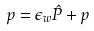Convert formula to latex. <formula><loc_0><loc_0><loc_500><loc_500>p = \epsilon _ { w } \hat { P } + p</formula> 